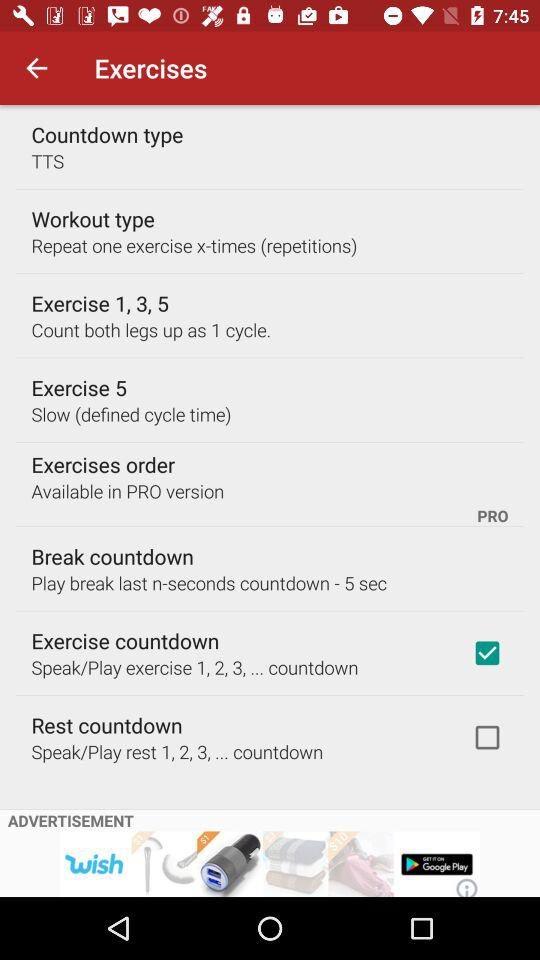What is the countdown type? The countdown type is TTS. 